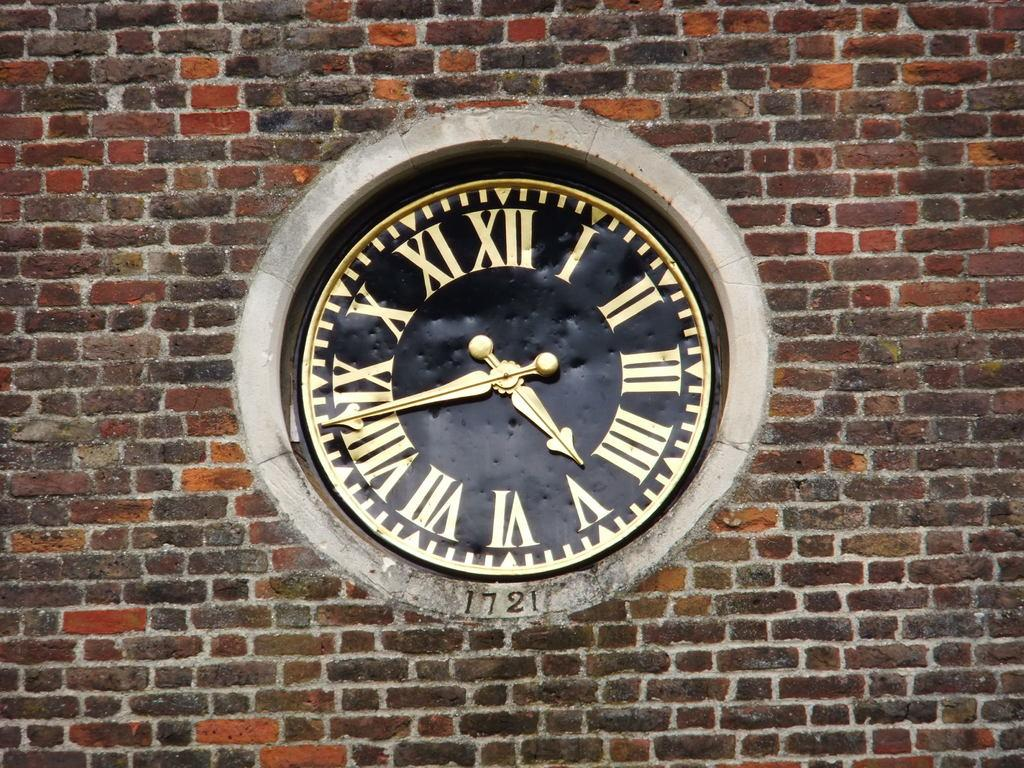<image>
Share a concise interpretation of the image provided. A black and gold clock on a brick wall has the time of 4:43. 